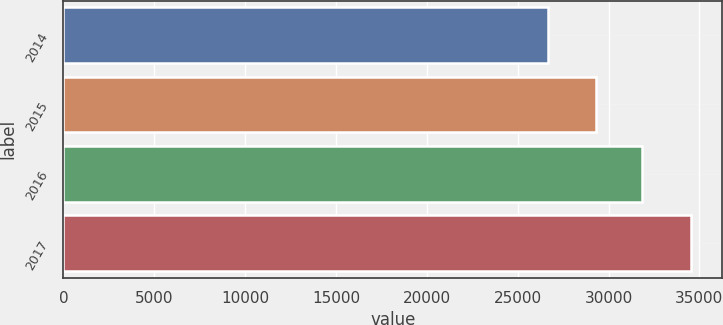Convert chart to OTSL. <chart><loc_0><loc_0><loc_500><loc_500><bar_chart><fcel>2014<fcel>2015<fcel>2016<fcel>2017<nl><fcel>26682<fcel>29299<fcel>31837<fcel>34529<nl></chart> 